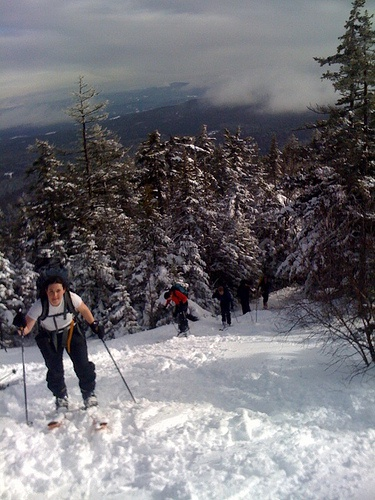Describe the objects in this image and their specific colors. I can see people in gray, black, darkgray, and brown tones, backpack in gray, black, and maroon tones, people in gray, black, and maroon tones, skis in gray, darkgray, and lightgray tones, and people in gray and black tones in this image. 